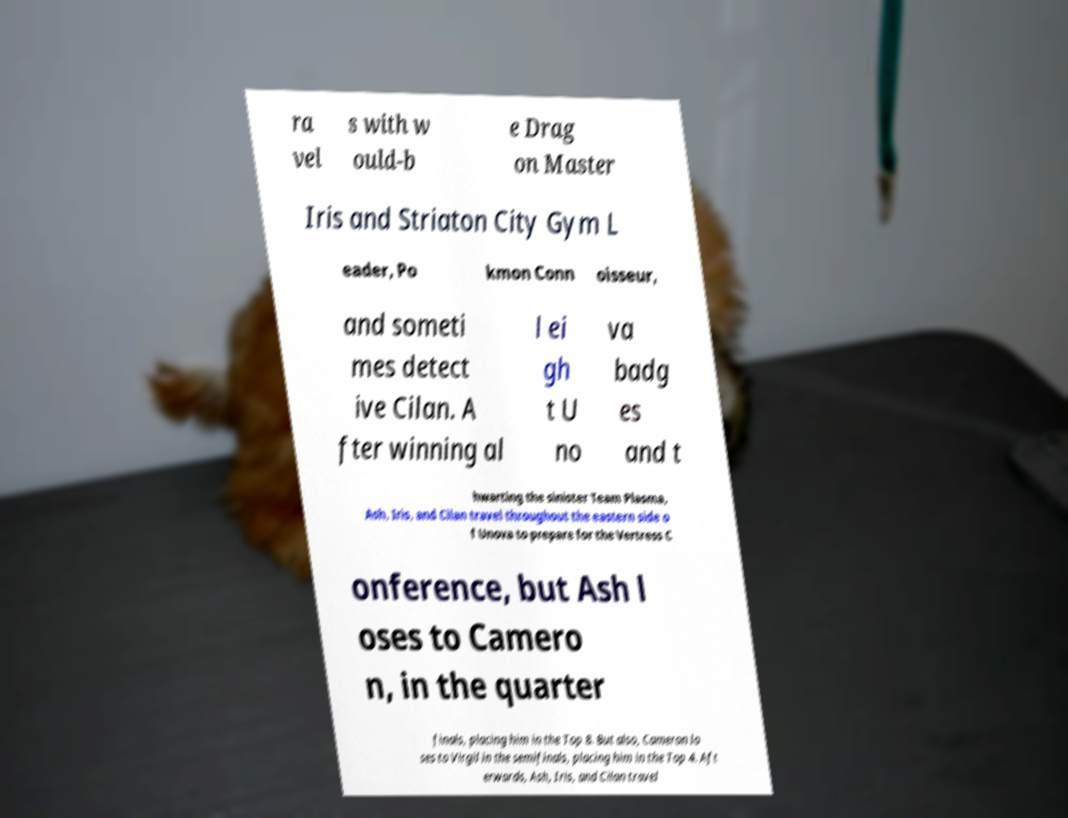For documentation purposes, I need the text within this image transcribed. Could you provide that? ra vel s with w ould-b e Drag on Master Iris and Striaton City Gym L eader, Po kmon Conn oisseur, and someti mes detect ive Cilan. A fter winning al l ei gh t U no va badg es and t hwarting the sinister Team Plasma, Ash, Iris, and Cilan travel throughout the eastern side o f Unova to prepare for the Vertress C onference, but Ash l oses to Camero n, in the quarter finals, placing him in the Top 8. But also, Cameron lo ses to Virgil in the semifinals, placing him in the Top 4. Aft erwards, Ash, Iris, and Cilan travel 